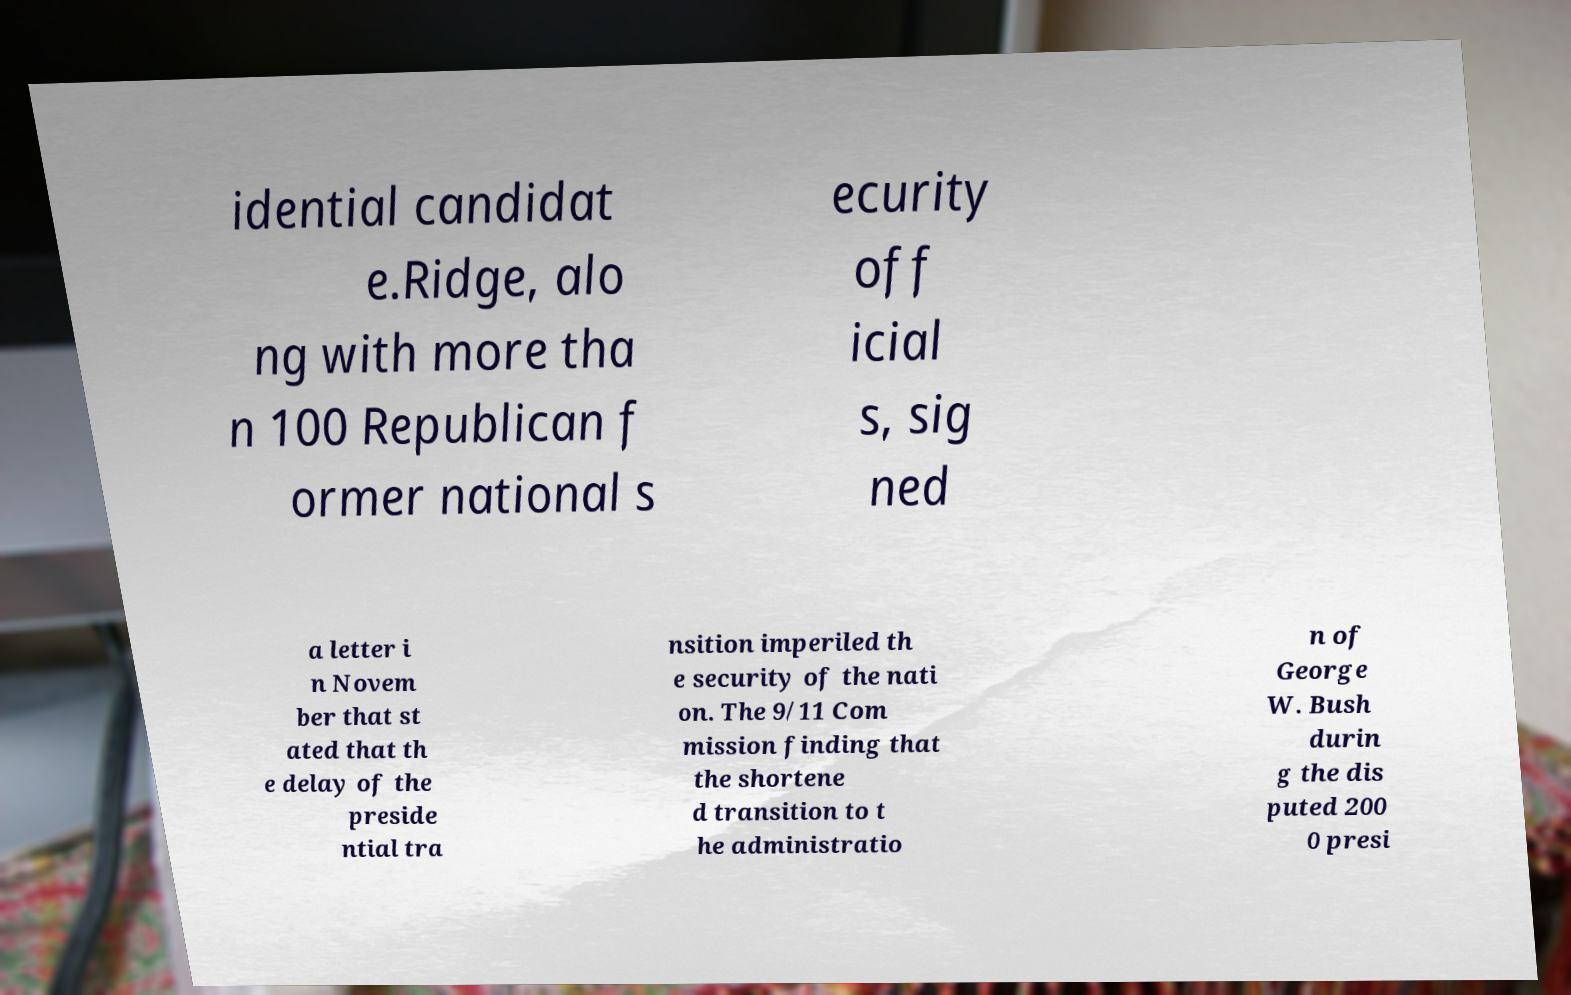Please identify and transcribe the text found in this image. idential candidat e.Ridge, alo ng with more tha n 100 Republican f ormer national s ecurity off icial s, sig ned a letter i n Novem ber that st ated that th e delay of the preside ntial tra nsition imperiled th e security of the nati on. The 9/11 Com mission finding that the shortene d transition to t he administratio n of George W. Bush durin g the dis puted 200 0 presi 